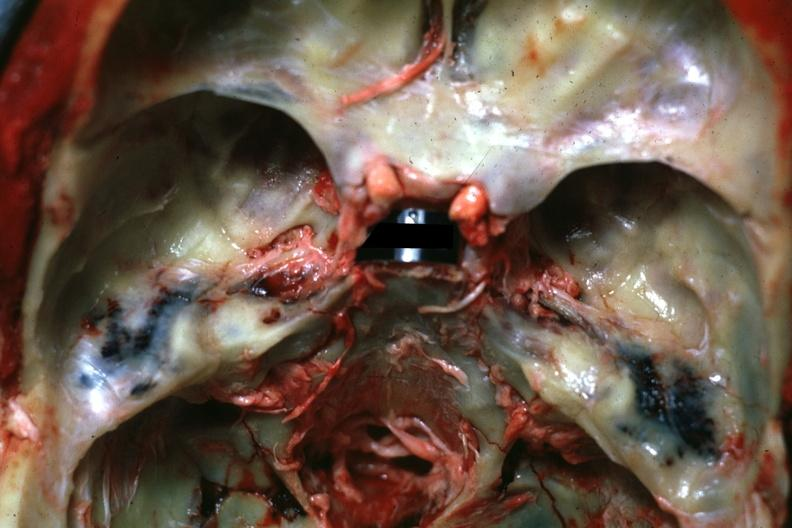what is present?
Answer the question using a single word or phrase. Basilar skull fracture 